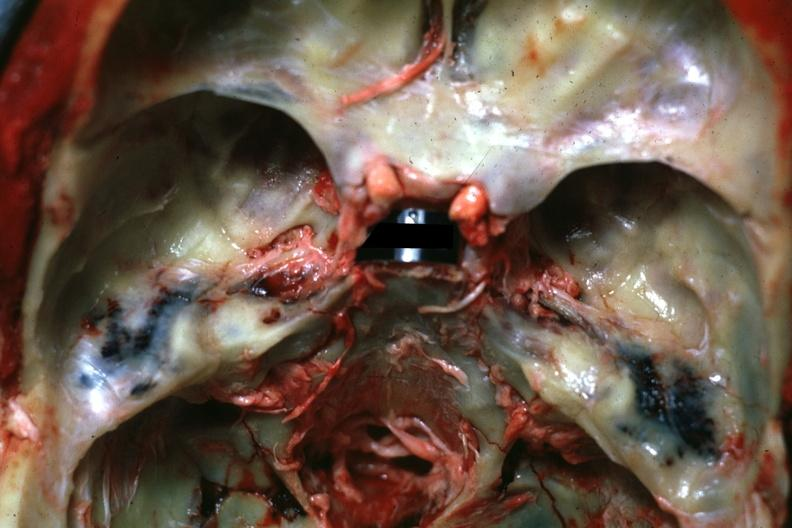what is present?
Answer the question using a single word or phrase. Basilar skull fracture 